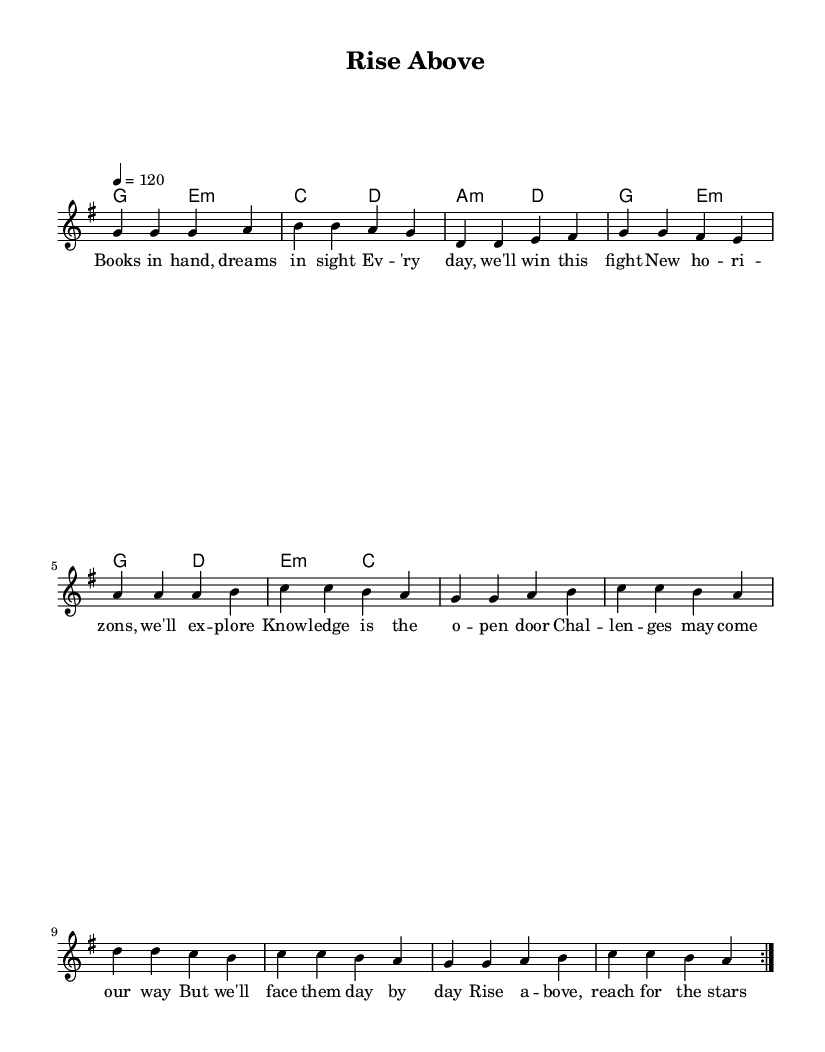What is the key signature of this music? The key signature shows one sharp, indicating that the piece is in G major. The absence of flats and the presence of F# confirm this.
Answer: G major What is the time signature of this piece? The time signature is indicated at the beginning of the score as 4/4. This means there are four beats in a measure and the quarter note gets one beat.
Answer: 4/4 What is the tempo marking for this piece? The tempo marking at the beginning specifies a quarter note equals 120 beats per minute, indicating a moderate tempo for the piece.
Answer: 120 How many measures are in the verse? By counting the measures in the verse section from the provided melody, there are 4 measures. The verse section is notated separately and contains these measures.
Answer: 4 What recurring lyrical theme is expressed in the chorus? The chorus emphasizes themes of aspiration and achievement, particularly focusing on academic excellence and personal growth, suggesting determination to succeed.
Answer: Academic excellence Which section comes directly before the chorus? The pre-chorus is the section that directly precedes the chorus, serving as a transition that builds up to the main theme.
Answer: Pre-Chorus Name one type of harmony featured in this composition. The score includes a mix of major and minor chords, specifically noting G major and E minor chords as foundational harmonies.
Answer: Major and minor chords 